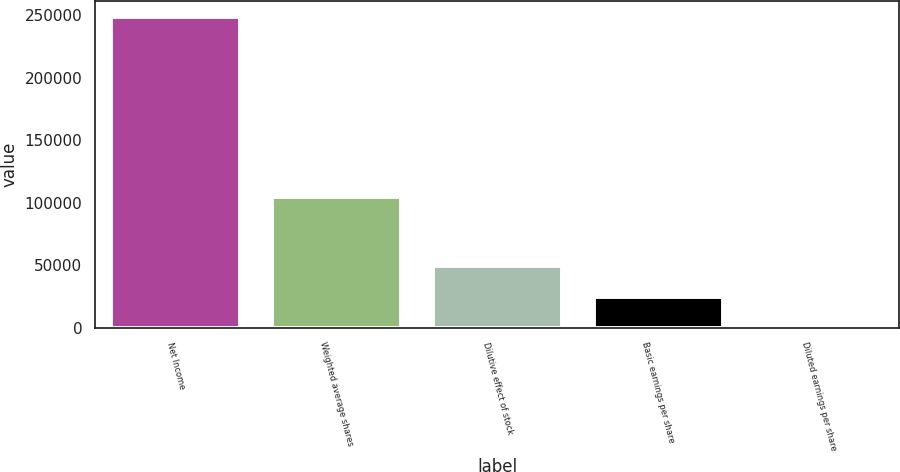Convert chart to OTSL. <chart><loc_0><loc_0><loc_500><loc_500><bar_chart><fcel>Net Income<fcel>Weighted average shares<fcel>Dilutive effect of stock<fcel>Basic earnings per share<fcel>Diluted earnings per share<nl><fcel>248867<fcel>104302<fcel>49775.9<fcel>24889.5<fcel>3.12<nl></chart> 